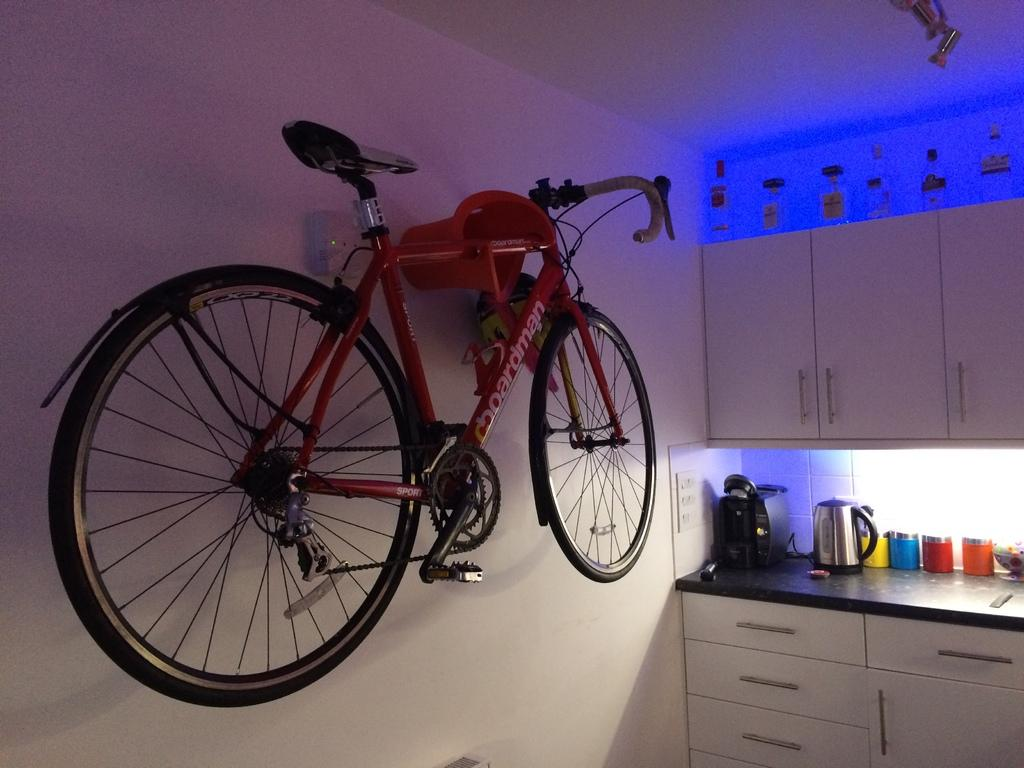What is the main object in the image? There is a bicycle in the image. What other objects can be seen in the image? There are cupboards, a kettle, bottles, and a bowl in the image. What type of surface is the bicycle resting on? The bicycle is resting against a wall in the image. What is the purpose of the kettle in the image? The kettle is likely used for boiling water. Can you see any fog in the image? There is no fog present in the image. Is there a fight happening in the image? There is no fight depicted in the image. 